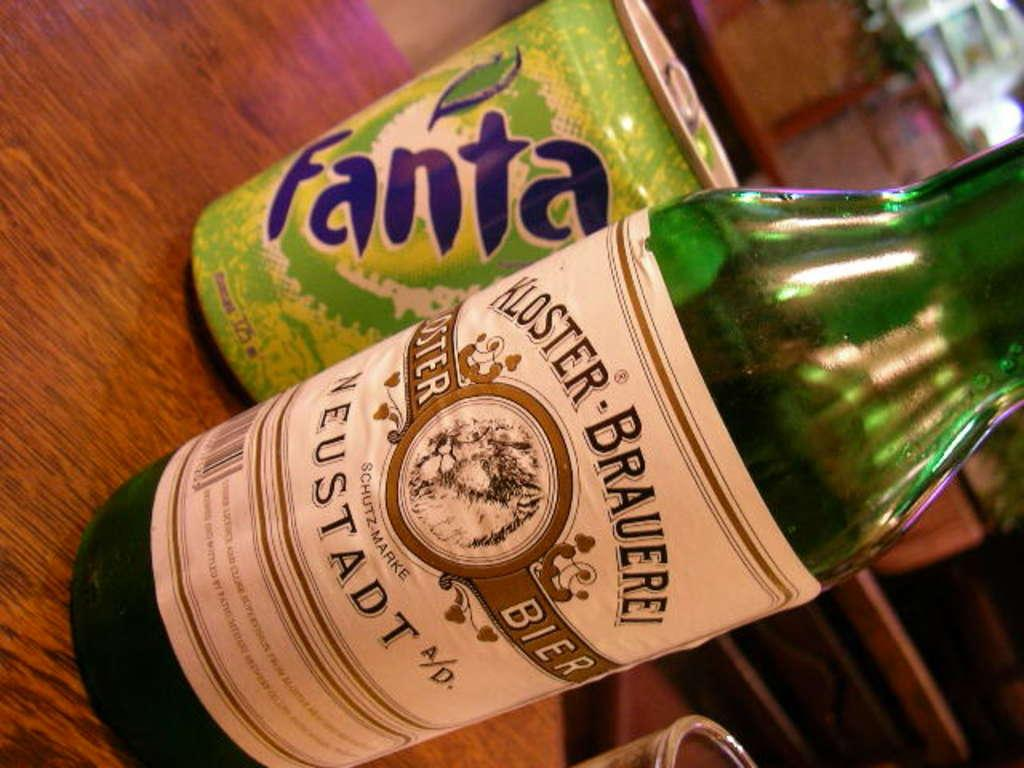Provide a one-sentence caption for the provided image. a can of fanta next to a bottle of kloster brauerei. 